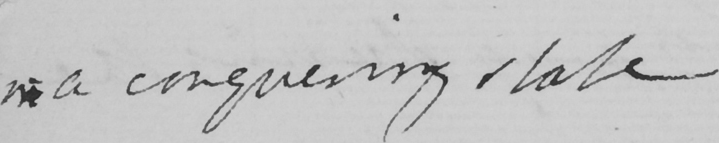Please provide the text content of this handwritten line. in a conquering state 